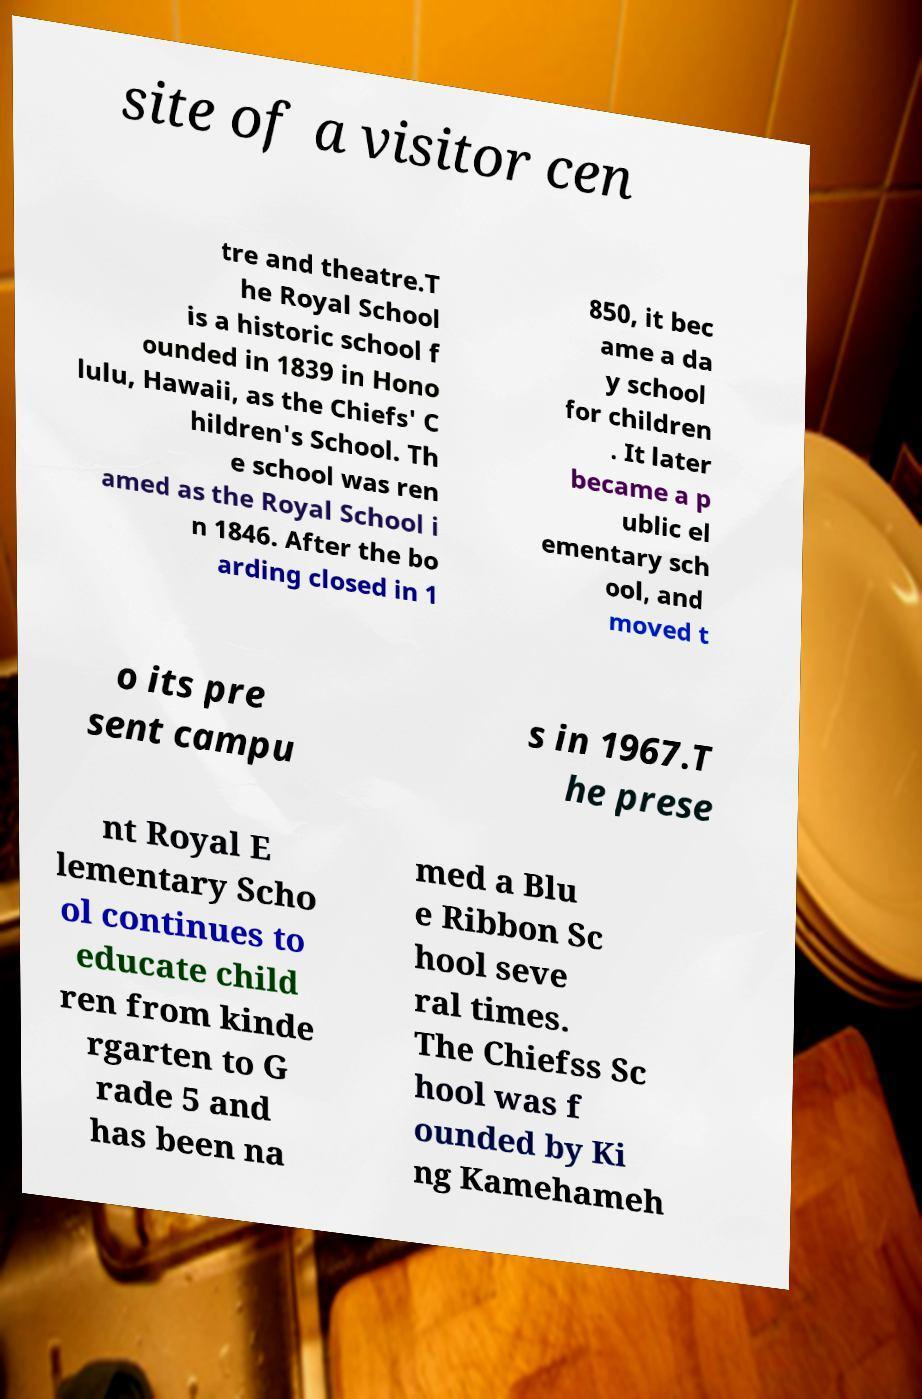For documentation purposes, I need the text within this image transcribed. Could you provide that? site of a visitor cen tre and theatre.T he Royal School is a historic school f ounded in 1839 in Hono lulu, Hawaii, as the Chiefs' C hildren's School. Th e school was ren amed as the Royal School i n 1846. After the bo arding closed in 1 850, it bec ame a da y school for children . It later became a p ublic el ementary sch ool, and moved t o its pre sent campu s in 1967.T he prese nt Royal E lementary Scho ol continues to educate child ren from kinde rgarten to G rade 5 and has been na med a Blu e Ribbon Sc hool seve ral times. The Chiefss Sc hool was f ounded by Ki ng Kamehameh 